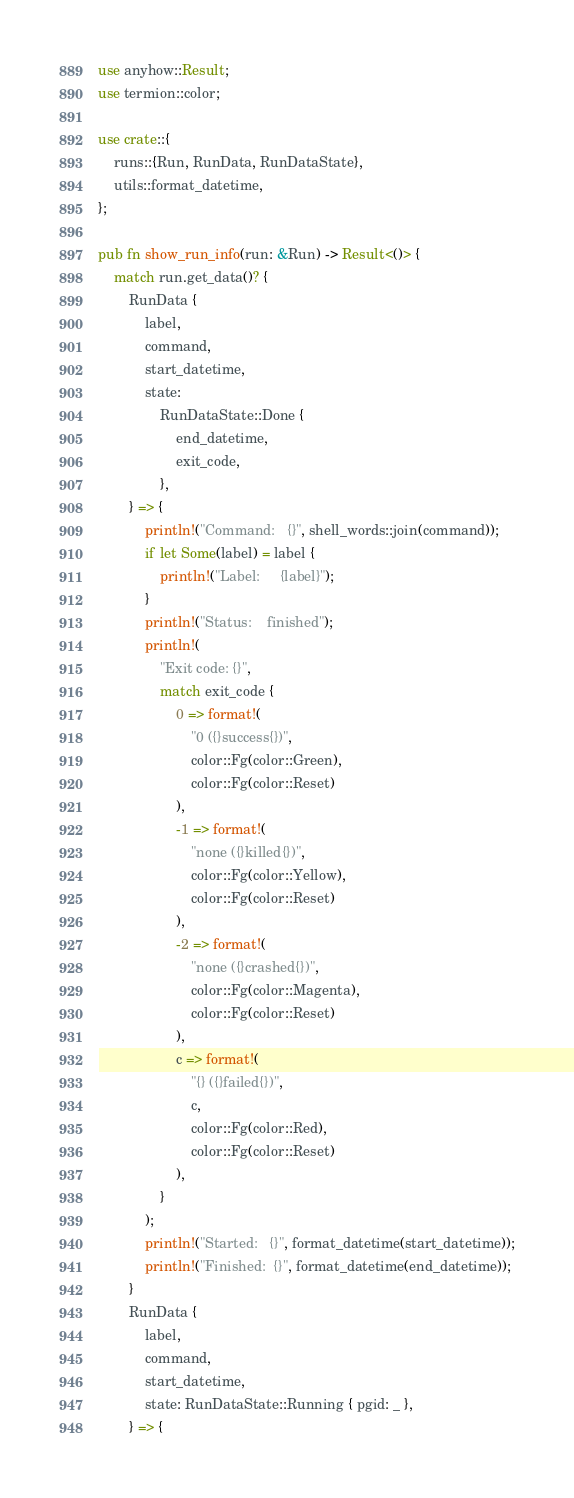<code> <loc_0><loc_0><loc_500><loc_500><_Rust_>use anyhow::Result;
use termion::color;

use crate::{
    runs::{Run, RunData, RunDataState},
    utils::format_datetime,
};

pub fn show_run_info(run: &Run) -> Result<()> {
    match run.get_data()? {
        RunData {
            label,
            command,
            start_datetime,
            state:
                RunDataState::Done {
                    end_datetime,
                    exit_code,
                },
        } => {
            println!("Command:   {}", shell_words::join(command));
            if let Some(label) = label {
                println!("Label:     {label}");
            }
            println!("Status:    finished");
            println!(
                "Exit code: {}",
                match exit_code {
                    0 => format!(
                        "0 ({}success{})",
                        color::Fg(color::Green),
                        color::Fg(color::Reset)
                    ),
                    -1 => format!(
                        "none ({}killed{})",
                        color::Fg(color::Yellow),
                        color::Fg(color::Reset)
                    ),
                    -2 => format!(
                        "none ({}crashed{})",
                        color::Fg(color::Magenta),
                        color::Fg(color::Reset)
                    ),
                    c => format!(
                        "{} ({}failed{})",
                        c,
                        color::Fg(color::Red),
                        color::Fg(color::Reset)
                    ),
                }
            );
            println!("Started:   {}", format_datetime(start_datetime));
            println!("Finished:  {}", format_datetime(end_datetime));
        }
        RunData {
            label,
            command,
            start_datetime,
            state: RunDataState::Running { pgid: _ },
        } => {</code> 